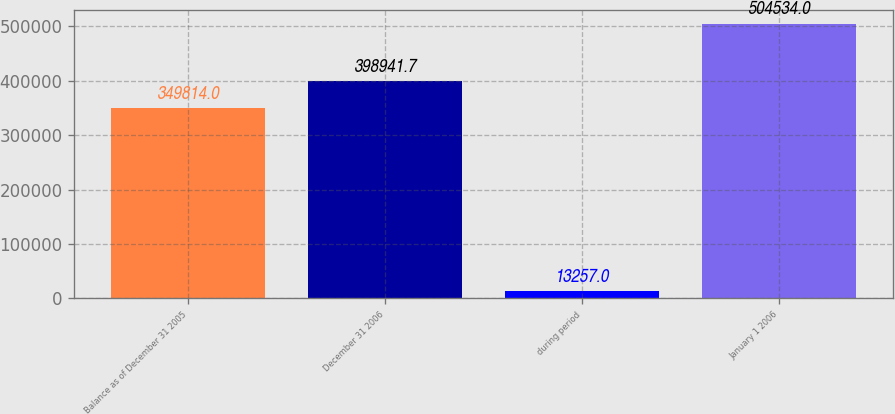Convert chart. <chart><loc_0><loc_0><loc_500><loc_500><bar_chart><fcel>Balance as of December 31 2005<fcel>December 31 2006<fcel>during period<fcel>January 1 2006<nl><fcel>349814<fcel>398942<fcel>13257<fcel>504534<nl></chart> 